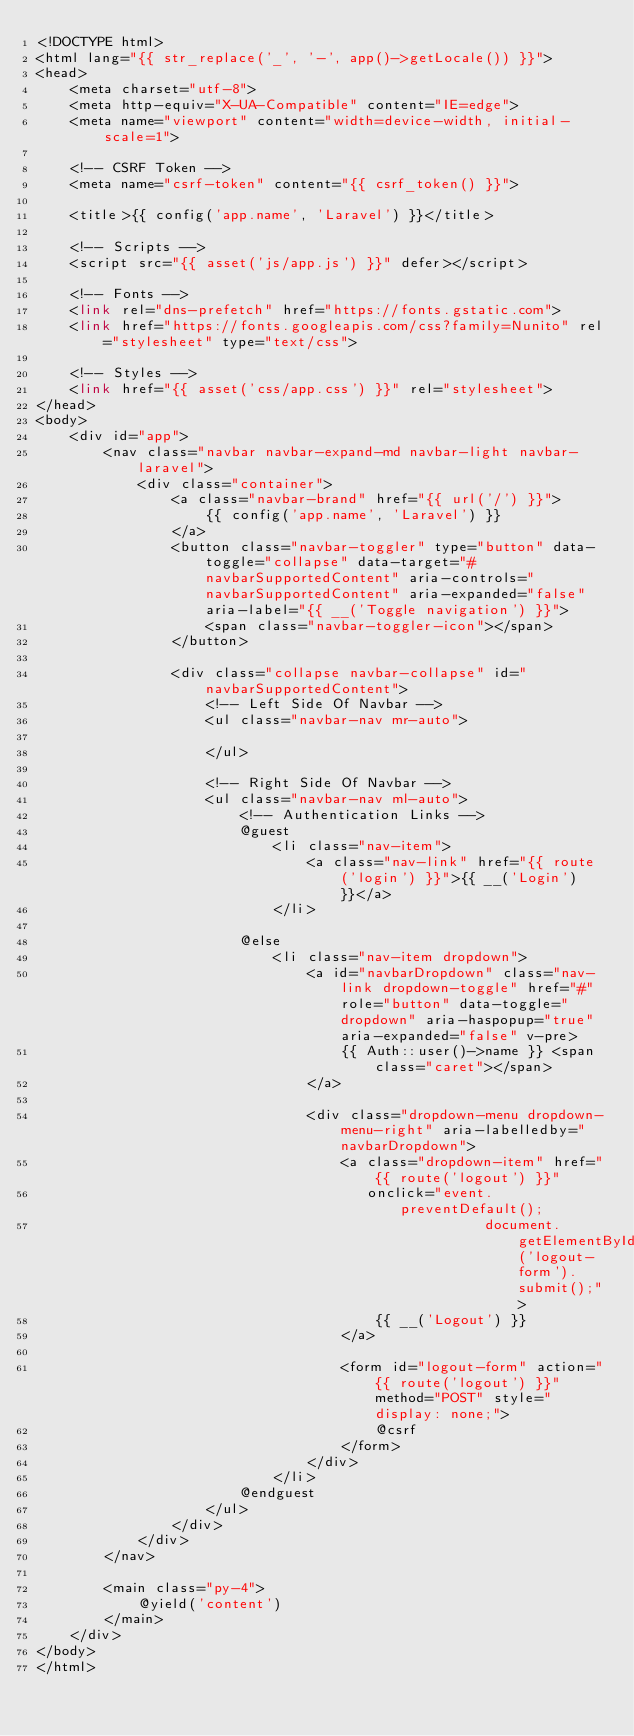Convert code to text. <code><loc_0><loc_0><loc_500><loc_500><_PHP_><!DOCTYPE html>
<html lang="{{ str_replace('_', '-', app()->getLocale()) }}">
<head>
    <meta charset="utf-8">
    <meta http-equiv="X-UA-Compatible" content="IE=edge">
    <meta name="viewport" content="width=device-width, initial-scale=1">

    <!-- CSRF Token -->
    <meta name="csrf-token" content="{{ csrf_token() }}">

    <title>{{ config('app.name', 'Laravel') }}</title>

    <!-- Scripts -->
    <script src="{{ asset('js/app.js') }}" defer></script>

    <!-- Fonts -->
    <link rel="dns-prefetch" href="https://fonts.gstatic.com">
    <link href="https://fonts.googleapis.com/css?family=Nunito" rel="stylesheet" type="text/css">

    <!-- Styles -->
    <link href="{{ asset('css/app.css') }}" rel="stylesheet">
</head>
<body>
    <div id="app">
        <nav class="navbar navbar-expand-md navbar-light navbar-laravel">
            <div class="container">
                <a class="navbar-brand" href="{{ url('/') }}">
                    {{ config('app.name', 'Laravel') }}
                </a>
                <button class="navbar-toggler" type="button" data-toggle="collapse" data-target="#navbarSupportedContent" aria-controls="navbarSupportedContent" aria-expanded="false" aria-label="{{ __('Toggle navigation') }}">
                    <span class="navbar-toggler-icon"></span>
                </button>

                <div class="collapse navbar-collapse" id="navbarSupportedContent">
                    <!-- Left Side Of Navbar -->
                    <ul class="navbar-nav mr-auto">

                    </ul>

                    <!-- Right Side Of Navbar -->
                    <ul class="navbar-nav ml-auto">
                        <!-- Authentication Links -->
                        @guest
                            <li class="nav-item">
                                <a class="nav-link" href="{{ route('login') }}">{{ __('Login') }}</a>
                            </li>
                           
                        @else
                            <li class="nav-item dropdown">
                                <a id="navbarDropdown" class="nav-link dropdown-toggle" href="#" role="button" data-toggle="dropdown" aria-haspopup="true" aria-expanded="false" v-pre>
                                    {{ Auth::user()->name }} <span class="caret"></span>
                                </a>

                                <div class="dropdown-menu dropdown-menu-right" aria-labelledby="navbarDropdown">
                                    <a class="dropdown-item" href="{{ route('logout') }}"
                                       onclick="event.preventDefault();
                                                     document.getElementById('logout-form').submit();">
                                        {{ __('Logout') }}
                                    </a>

                                    <form id="logout-form" action="{{ route('logout') }}" method="POST" style="display: none;">
                                        @csrf
                                    </form>
                                </div>
                            </li>
                        @endguest
                    </ul>
                </div>
            </div>
        </nav>

        <main class="py-4">
            @yield('content')
        </main>
    </div>
</body>
</html>
</code> 